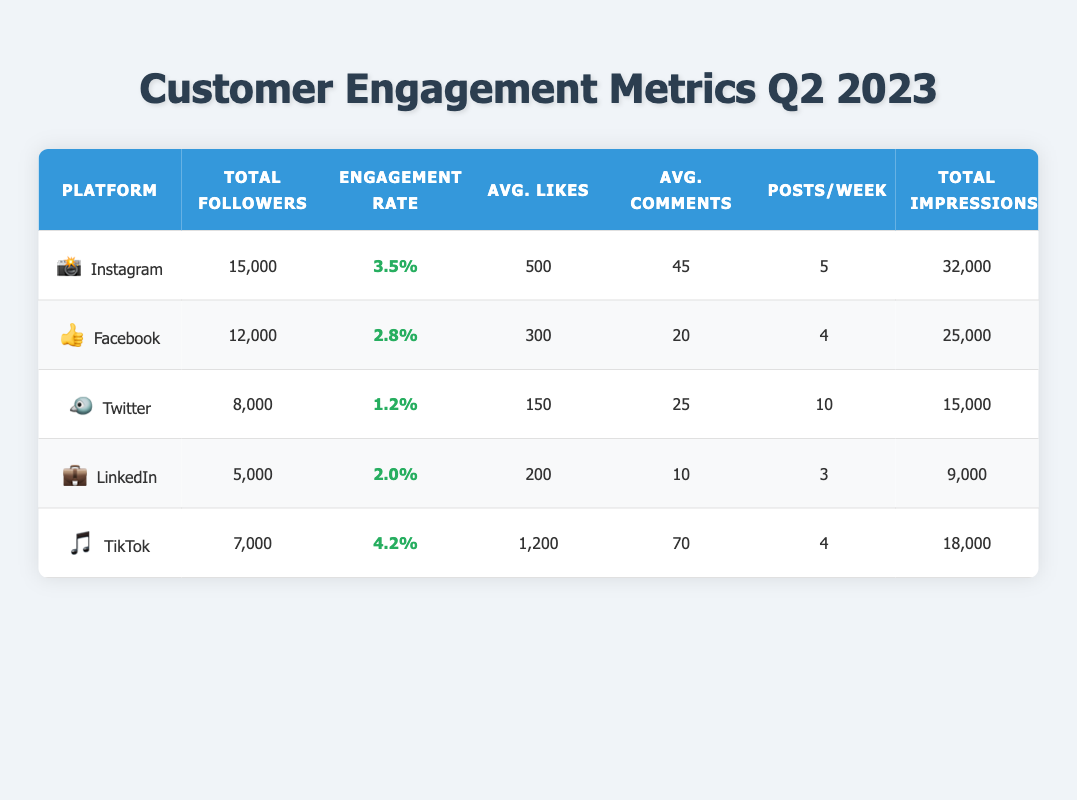What is the total number of followers across all platforms? To find the total number of followers, we sum the followers from each platform: 15000 (Instagram) + 12000 (Facebook) + 8000 (Twitter) + 5000 (LinkedIn) + 7000 (TikTok). This gives us: 15000 + 12000 + 8000 + 5000 + 7000 = 50000.
Answer: 50000 Which platform has the highest engagement rate? By reviewing the engagement rates, we can see that TikTok has the highest rate at 4.2%, while the others are lower: Instagram 3.5%, Facebook 2.8%, Twitter 1.2%, and LinkedIn 2.0%.
Answer: TikTok What is the average number of posts per week across all platforms? We need to determine the average by summing the number of posts per week for each platform: 5 (Instagram) + 4 (Facebook) + 10 (Twitter) + 3 (LinkedIn) + 4 (TikTok) = 26. Then, we divide by the number of platforms, which is 5. So the average is 26/5 = 5.2.
Answer: 5.2 Is the engagement rate of Instagram higher than that of Facebook? The engagement rates show Instagram at 3.5% and Facebook at 2.8%. Since 3.5% is greater than 2.8%, this statement is true.
Answer: Yes What is the difference in total impressions between Instagram and LinkedIn? To find the difference, we subtract the total impressions of LinkedIn from Instagram: 32000 (Instagram) - 9000 (LinkedIn) = 23000.
Answer: 23000 If we consider average likes per post, which platform has the lowest value? Comparing the average likes per post: Instagram 500, Facebook 300, Twitter 150, LinkedIn 200, and TikTok 1200, we find that Twitter has the lowest average likes at 150.
Answer: Twitter How many total comments did TikTok receive if it had an average of 70 comments per video and posted 4 videos per week? We will calculate the total comments by multiplying the average comments per video by the number of videos per week and multiplying that by the number of weeks in Q2 (approximately 13 weeks): 70 (average comments) * 4 (videos per week) * 13 = 3640.
Answer: 3640 Which platform has more followers, Facebook or TikTok? Facebook has 12000 followers and TikTok has 7000 followers. Since 12000 is greater than 7000, Facebook has more followers than TikTok.
Answer: Facebook 